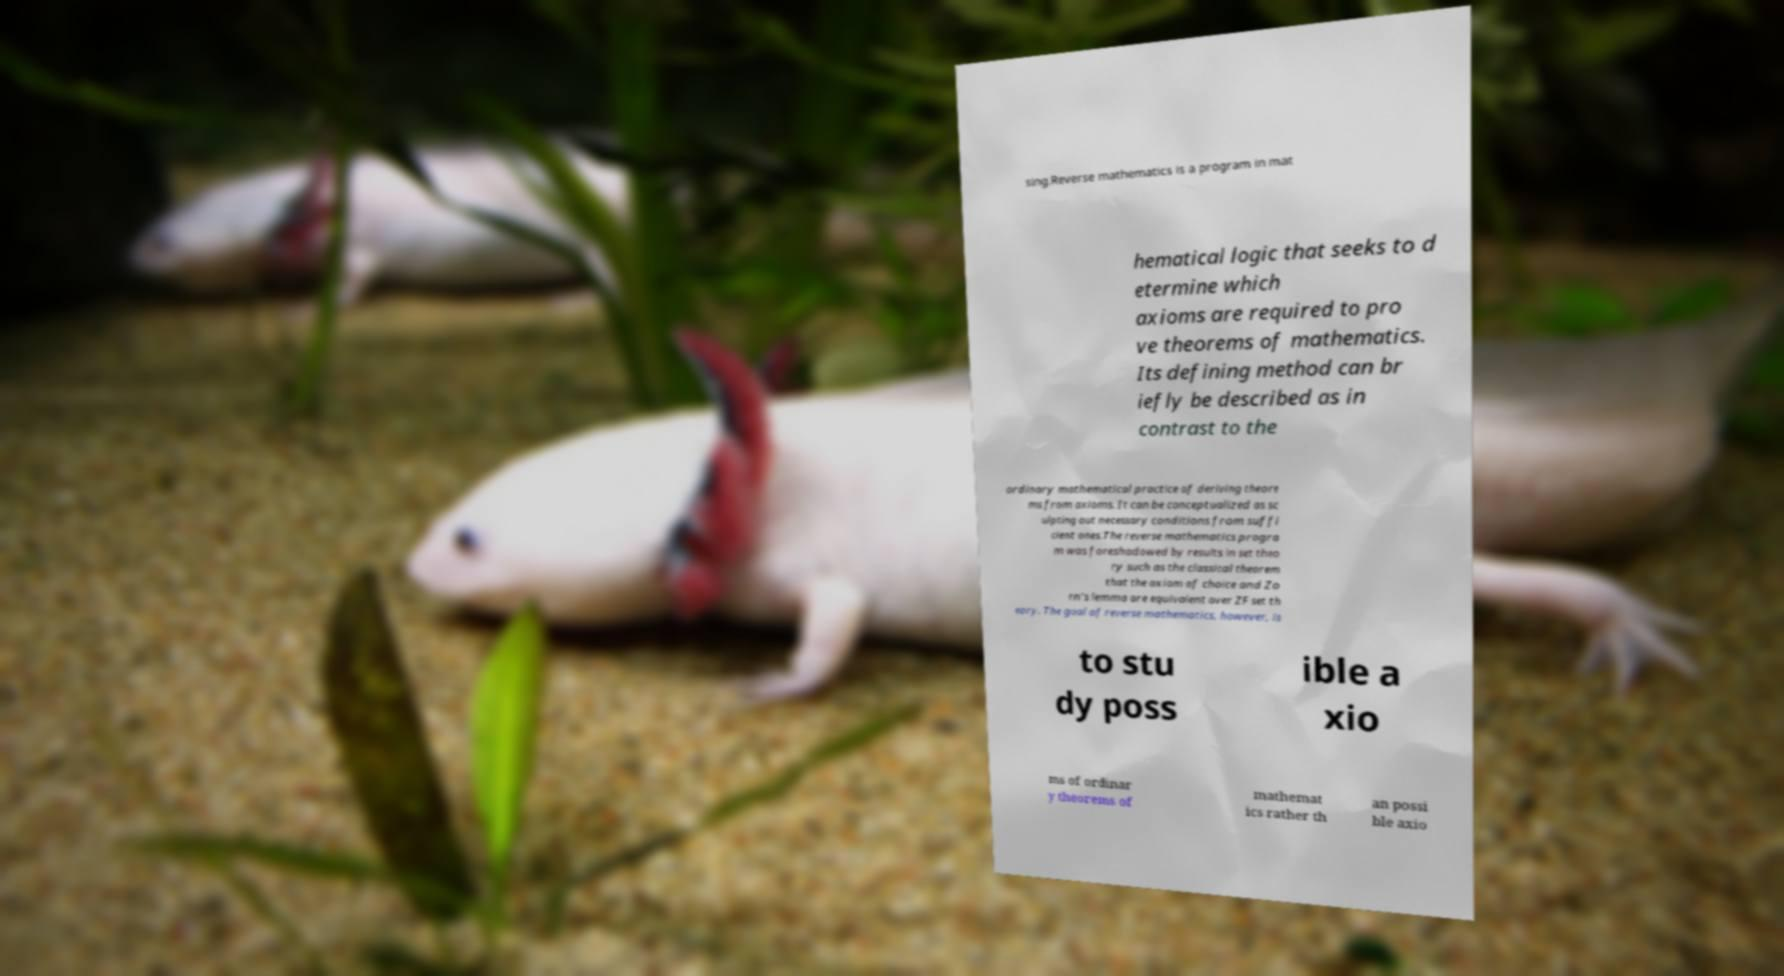Could you assist in decoding the text presented in this image and type it out clearly? sing.Reverse mathematics is a program in mat hematical logic that seeks to d etermine which axioms are required to pro ve theorems of mathematics. Its defining method can br iefly be described as in contrast to the ordinary mathematical practice of deriving theore ms from axioms. It can be conceptualized as sc ulpting out necessary conditions from suffi cient ones.The reverse mathematics progra m was foreshadowed by results in set theo ry such as the classical theorem that the axiom of choice and Zo rn's lemma are equivalent over ZF set th eory. The goal of reverse mathematics, however, is to stu dy poss ible a xio ms of ordinar y theorems of mathemat ics rather th an possi ble axio 